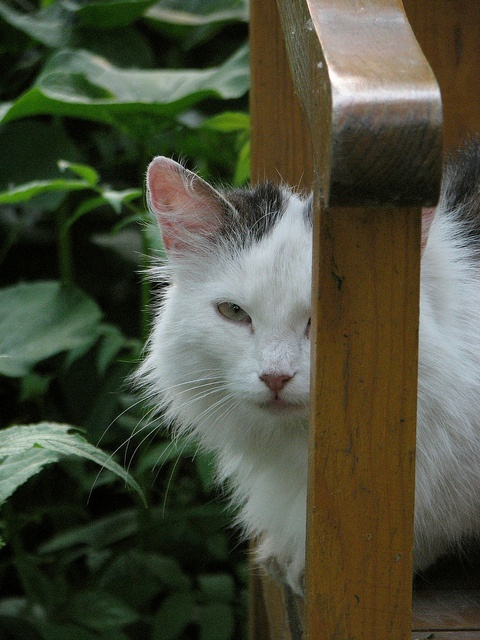Describe the objects in this image and their specific colors. I can see bench in black, maroon, olive, and darkgray tones and cat in black, darkgray, gray, and lightgray tones in this image. 